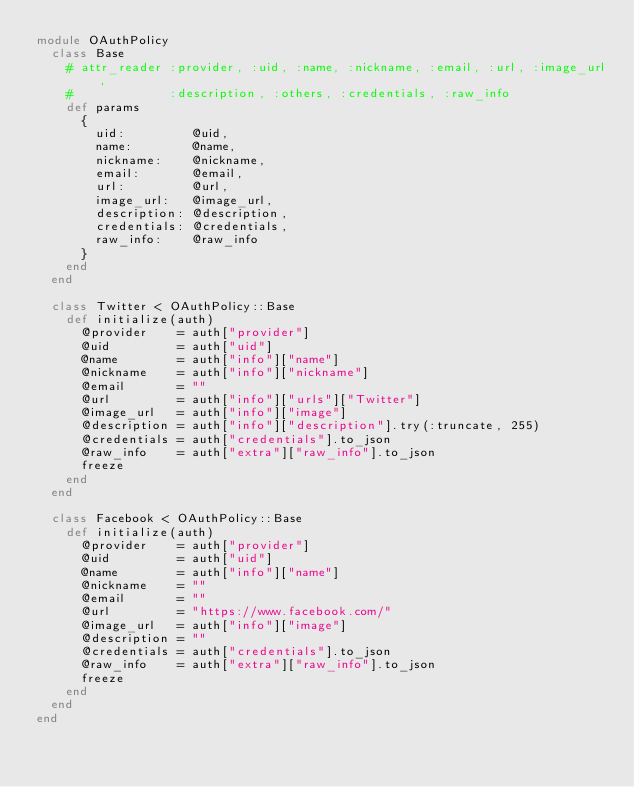Convert code to text. <code><loc_0><loc_0><loc_500><loc_500><_Ruby_>module OAuthPolicy
  class Base
    # attr_reader :provider, :uid, :name, :nickname, :email, :url, :image_url,
    #             :description, :others, :credentials, :raw_info
    def params
      {
        uid:         @uid,
        name:        @name,
        nickname:    @nickname,
        email:       @email,
        url:         @url,
        image_url:   @image_url,
        description: @description,
        credentials: @credentials,
        raw_info:    @raw_info
      }
    end
  end

  class Twitter < OAuthPolicy::Base
    def initialize(auth)
      @provider    = auth["provider"]
      @uid         = auth["uid"]
      @name        = auth["info"]["name"]
      @nickname    = auth["info"]["nickname"]
      @email       = ""
      @url         = auth["info"]["urls"]["Twitter"]
      @image_url   = auth["info"]["image"]
      @description = auth["info"]["description"].try(:truncate, 255)
      @credentials = auth["credentials"].to_json
      @raw_info    = auth["extra"]["raw_info"].to_json
      freeze
    end
  end

  class Facebook < OAuthPolicy::Base
    def initialize(auth)
      @provider    = auth["provider"]
      @uid         = auth["uid"]
      @name        = auth["info"]["name"]
      @nickname    = ""
      @email       = ""
      @url         = "https://www.facebook.com/"
      @image_url   = auth["info"]["image"]
      @description = ""
      @credentials = auth["credentials"].to_json
      @raw_info    = auth["extra"]["raw_info"].to_json
      freeze
    end
  end
end
</code> 